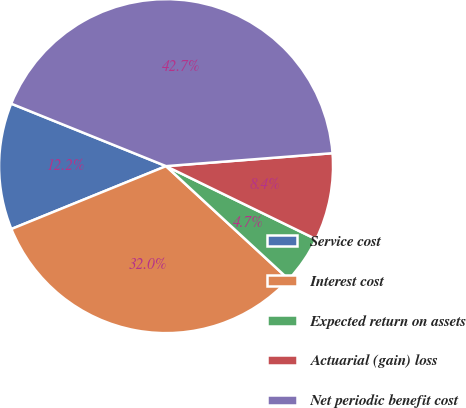Convert chart. <chart><loc_0><loc_0><loc_500><loc_500><pie_chart><fcel>Service cost<fcel>Interest cost<fcel>Expected return on assets<fcel>Actuarial (gain) loss<fcel>Net periodic benefit cost<nl><fcel>12.25%<fcel>31.99%<fcel>4.65%<fcel>8.45%<fcel>42.66%<nl></chart> 